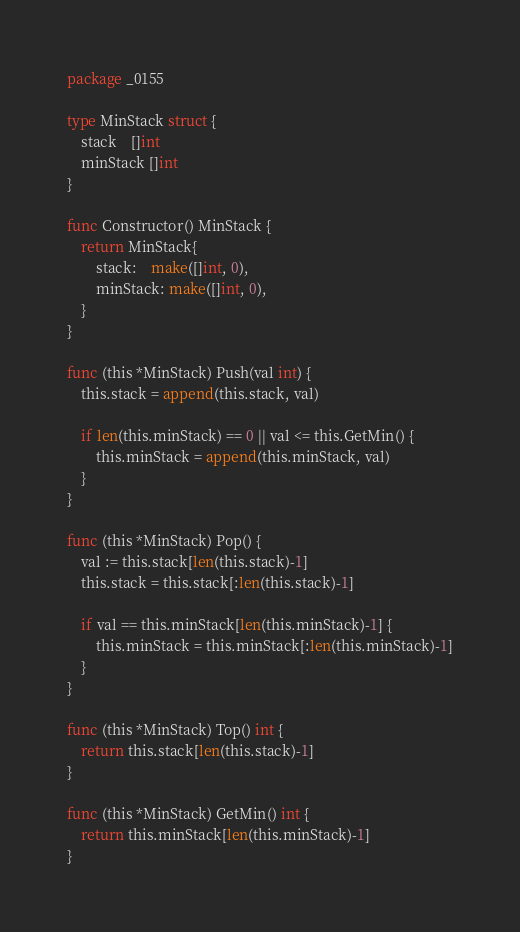Convert code to text. <code><loc_0><loc_0><loc_500><loc_500><_Go_>package _0155

type MinStack struct {
    stack    []int
    minStack []int
}

func Constructor() MinStack {
    return MinStack{
        stack:    make([]int, 0),
        minStack: make([]int, 0),
    }
}

func (this *MinStack) Push(val int) {
    this.stack = append(this.stack, val)

    if len(this.minStack) == 0 || val <= this.GetMin() {
        this.minStack = append(this.minStack, val)
    }
}

func (this *MinStack) Pop() {
    val := this.stack[len(this.stack)-1]
    this.stack = this.stack[:len(this.stack)-1]

    if val == this.minStack[len(this.minStack)-1] {
        this.minStack = this.minStack[:len(this.minStack)-1]
    }
}

func (this *MinStack) Top() int {
    return this.stack[len(this.stack)-1]
}

func (this *MinStack) GetMin() int {
    return this.minStack[len(this.minStack)-1]
}
</code> 